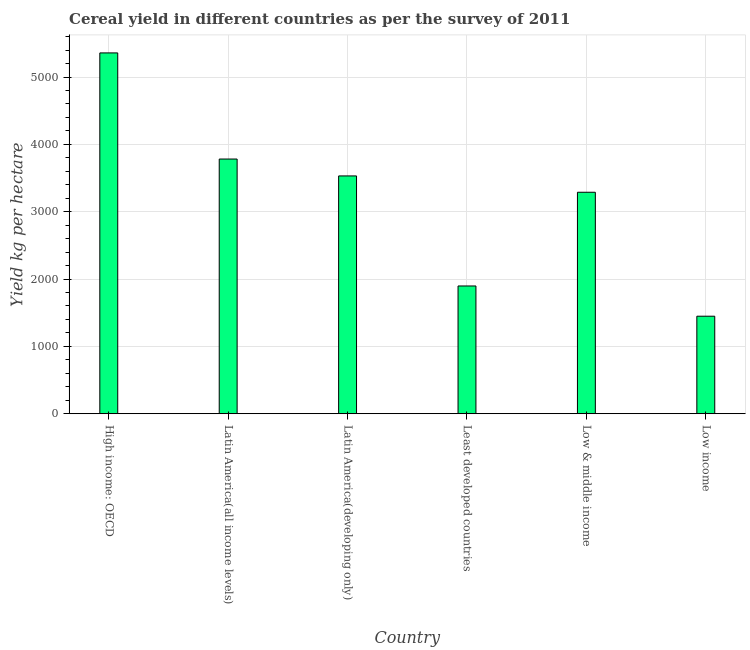Does the graph contain grids?
Your answer should be very brief. Yes. What is the title of the graph?
Provide a short and direct response. Cereal yield in different countries as per the survey of 2011. What is the label or title of the X-axis?
Provide a short and direct response. Country. What is the label or title of the Y-axis?
Your answer should be very brief. Yield kg per hectare. What is the cereal yield in Low & middle income?
Give a very brief answer. 3288.9. Across all countries, what is the maximum cereal yield?
Keep it short and to the point. 5357.99. Across all countries, what is the minimum cereal yield?
Make the answer very short. 1448.28. In which country was the cereal yield maximum?
Offer a terse response. High income: OECD. What is the sum of the cereal yield?
Give a very brief answer. 1.93e+04. What is the difference between the cereal yield in Low & middle income and Low income?
Your response must be concise. 1840.62. What is the average cereal yield per country?
Offer a terse response. 3217.62. What is the median cereal yield?
Your response must be concise. 3410.05. What is the ratio of the cereal yield in Latin America(all income levels) to that in Low income?
Your answer should be compact. 2.61. Is the difference between the cereal yield in Latin America(all income levels) and Latin America(developing only) greater than the difference between any two countries?
Provide a succinct answer. No. What is the difference between the highest and the second highest cereal yield?
Your answer should be very brief. 1575.79. Is the sum of the cereal yield in Least developed countries and Low income greater than the maximum cereal yield across all countries?
Offer a terse response. No. What is the difference between the highest and the lowest cereal yield?
Your answer should be compact. 3909.71. In how many countries, is the cereal yield greater than the average cereal yield taken over all countries?
Keep it short and to the point. 4. Are all the bars in the graph horizontal?
Your response must be concise. No. How many countries are there in the graph?
Your answer should be very brief. 6. Are the values on the major ticks of Y-axis written in scientific E-notation?
Ensure brevity in your answer.  No. What is the Yield kg per hectare of High income: OECD?
Provide a short and direct response. 5357.99. What is the Yield kg per hectare of Latin America(all income levels)?
Make the answer very short. 3782.2. What is the Yield kg per hectare in Latin America(developing only)?
Your answer should be compact. 3531.2. What is the Yield kg per hectare in Least developed countries?
Give a very brief answer. 1897.15. What is the Yield kg per hectare in Low & middle income?
Your answer should be very brief. 3288.9. What is the Yield kg per hectare in Low income?
Ensure brevity in your answer.  1448.28. What is the difference between the Yield kg per hectare in High income: OECD and Latin America(all income levels)?
Your answer should be compact. 1575.79. What is the difference between the Yield kg per hectare in High income: OECD and Latin America(developing only)?
Make the answer very short. 1826.79. What is the difference between the Yield kg per hectare in High income: OECD and Least developed countries?
Offer a terse response. 3460.84. What is the difference between the Yield kg per hectare in High income: OECD and Low & middle income?
Provide a short and direct response. 2069.09. What is the difference between the Yield kg per hectare in High income: OECD and Low income?
Give a very brief answer. 3909.71. What is the difference between the Yield kg per hectare in Latin America(all income levels) and Latin America(developing only)?
Offer a very short reply. 251. What is the difference between the Yield kg per hectare in Latin America(all income levels) and Least developed countries?
Offer a very short reply. 1885.05. What is the difference between the Yield kg per hectare in Latin America(all income levels) and Low & middle income?
Your answer should be compact. 493.3. What is the difference between the Yield kg per hectare in Latin America(all income levels) and Low income?
Make the answer very short. 2333.91. What is the difference between the Yield kg per hectare in Latin America(developing only) and Least developed countries?
Ensure brevity in your answer.  1634.06. What is the difference between the Yield kg per hectare in Latin America(developing only) and Low & middle income?
Give a very brief answer. 242.3. What is the difference between the Yield kg per hectare in Latin America(developing only) and Low income?
Your answer should be compact. 2082.92. What is the difference between the Yield kg per hectare in Least developed countries and Low & middle income?
Give a very brief answer. -1391.75. What is the difference between the Yield kg per hectare in Least developed countries and Low income?
Your answer should be compact. 448.86. What is the difference between the Yield kg per hectare in Low & middle income and Low income?
Your answer should be compact. 1840.62. What is the ratio of the Yield kg per hectare in High income: OECD to that in Latin America(all income levels)?
Give a very brief answer. 1.42. What is the ratio of the Yield kg per hectare in High income: OECD to that in Latin America(developing only)?
Keep it short and to the point. 1.52. What is the ratio of the Yield kg per hectare in High income: OECD to that in Least developed countries?
Make the answer very short. 2.82. What is the ratio of the Yield kg per hectare in High income: OECD to that in Low & middle income?
Make the answer very short. 1.63. What is the ratio of the Yield kg per hectare in High income: OECD to that in Low income?
Offer a terse response. 3.7. What is the ratio of the Yield kg per hectare in Latin America(all income levels) to that in Latin America(developing only)?
Make the answer very short. 1.07. What is the ratio of the Yield kg per hectare in Latin America(all income levels) to that in Least developed countries?
Give a very brief answer. 1.99. What is the ratio of the Yield kg per hectare in Latin America(all income levels) to that in Low & middle income?
Provide a succinct answer. 1.15. What is the ratio of the Yield kg per hectare in Latin America(all income levels) to that in Low income?
Give a very brief answer. 2.61. What is the ratio of the Yield kg per hectare in Latin America(developing only) to that in Least developed countries?
Make the answer very short. 1.86. What is the ratio of the Yield kg per hectare in Latin America(developing only) to that in Low & middle income?
Provide a succinct answer. 1.07. What is the ratio of the Yield kg per hectare in Latin America(developing only) to that in Low income?
Give a very brief answer. 2.44. What is the ratio of the Yield kg per hectare in Least developed countries to that in Low & middle income?
Provide a succinct answer. 0.58. What is the ratio of the Yield kg per hectare in Least developed countries to that in Low income?
Your answer should be very brief. 1.31. What is the ratio of the Yield kg per hectare in Low & middle income to that in Low income?
Your response must be concise. 2.27. 